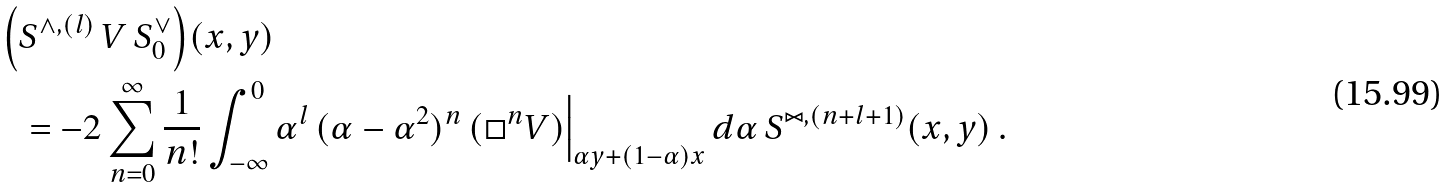Convert formula to latex. <formula><loc_0><loc_0><loc_500><loc_500>\Big ( & S ^ { \wedge , ( l ) } \, V \, S ^ { \vee } _ { 0 } \Big ) ( x , y ) \\ & = - 2 \sum _ { n = 0 } ^ { \infty } \frac { 1 } { n ! } \int _ { - \infty } ^ { 0 } \alpha ^ { l } \, ( \alpha - \alpha ^ { 2 } ) ^ { n } \, ( \Box ^ { n } V ) \Big | _ { \alpha y + ( 1 - \alpha ) x } \, d \alpha \, S ^ { \bowtie , ( n + l + 1 ) } ( x , y ) \, .</formula> 